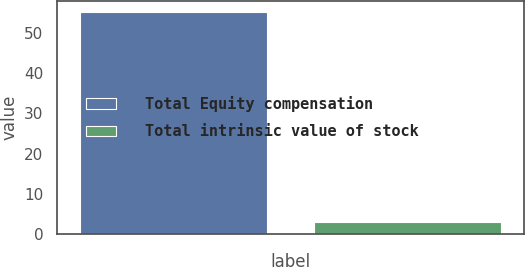Convert chart. <chart><loc_0><loc_0><loc_500><loc_500><bar_chart><fcel>Total Equity compensation<fcel>Total intrinsic value of stock<nl><fcel>55<fcel>3<nl></chart> 